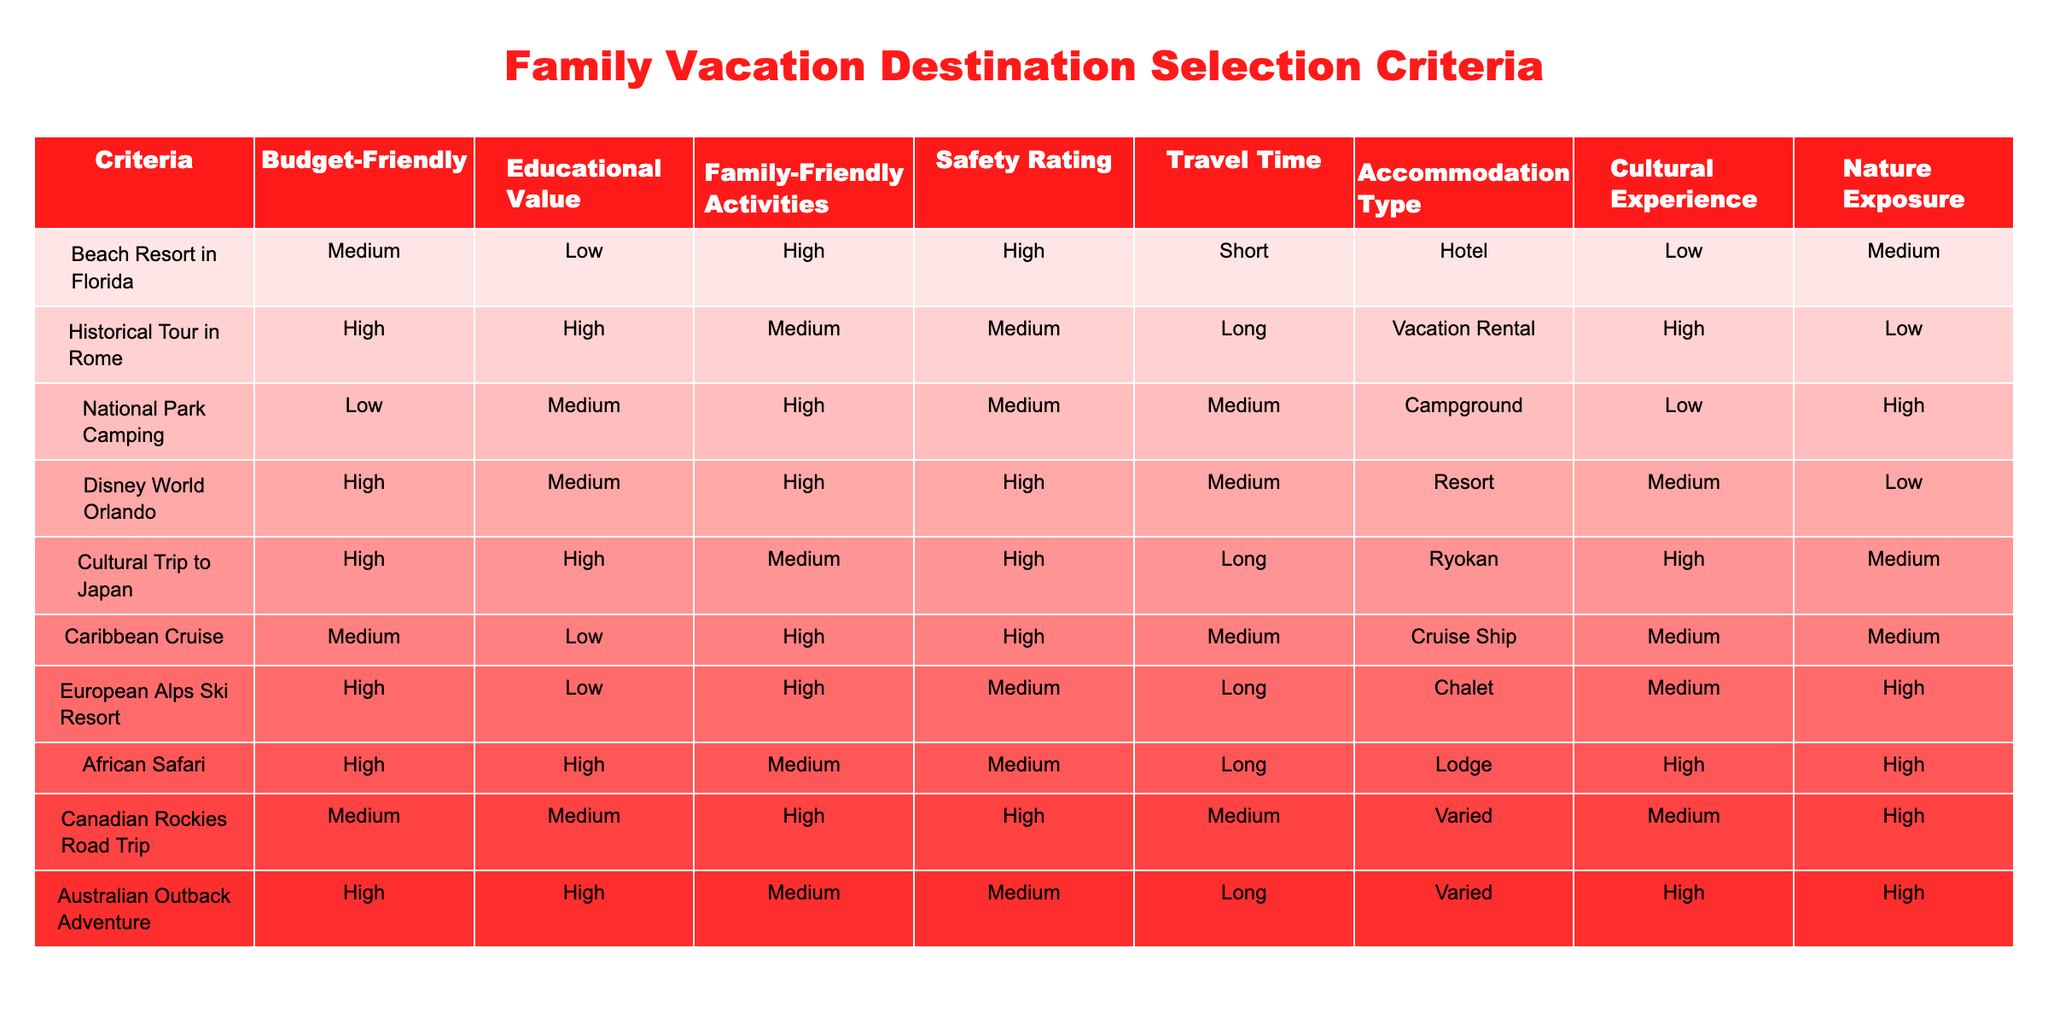What is the safety rating of the Caribbean Cruise? The safety rating of the Caribbean Cruise can be found in the table under the "Safety Rating" column. It indicates that the safety rating for this vacation option is "High."
Answer: High Which destination has the highest educational value? To determine the destination with the highest educational value, I will review the "Educational Value" column for all entries. The Historical Tour in Rome and the Cultural Trip to Japan both have "High" value, but since we're looking for the highest rated, it would be either of those two.
Answer: Historical Tour in Rome or Cultural Trip to Japan How many vacation options have a medium budget-friendliness? I need to count how many entries in the "Budget-Friendly" column are marked as "Medium." Upon reviewing, I find three options: Beach Resort in Florida, Caribbean Cruise, and Canadian Rockies Road Trip.
Answer: 3 Is Disney World Orlando more family-friendly than the Historical Tour in Rome? This comparison can be made by looking at the "Family-Friendly Activities" column for both destinations. Disney World Orlando has a "High" rating while the Historical Tour in Rome has a "Medium" rating, indicating that Disney World Orlando is indeed more family-friendly.
Answer: Yes Which destination offers the best balance of cultural experience and nature exposure? First, I will assess both the "Cultural Experience" and "Nature Exposure" columns for each destination. The Australian Outback Adventure has a "High" rating in both columns, suggesting it provides a good balance between cultural experience and nature exposure compared to the others.
Answer: Australian Outback Adventure 